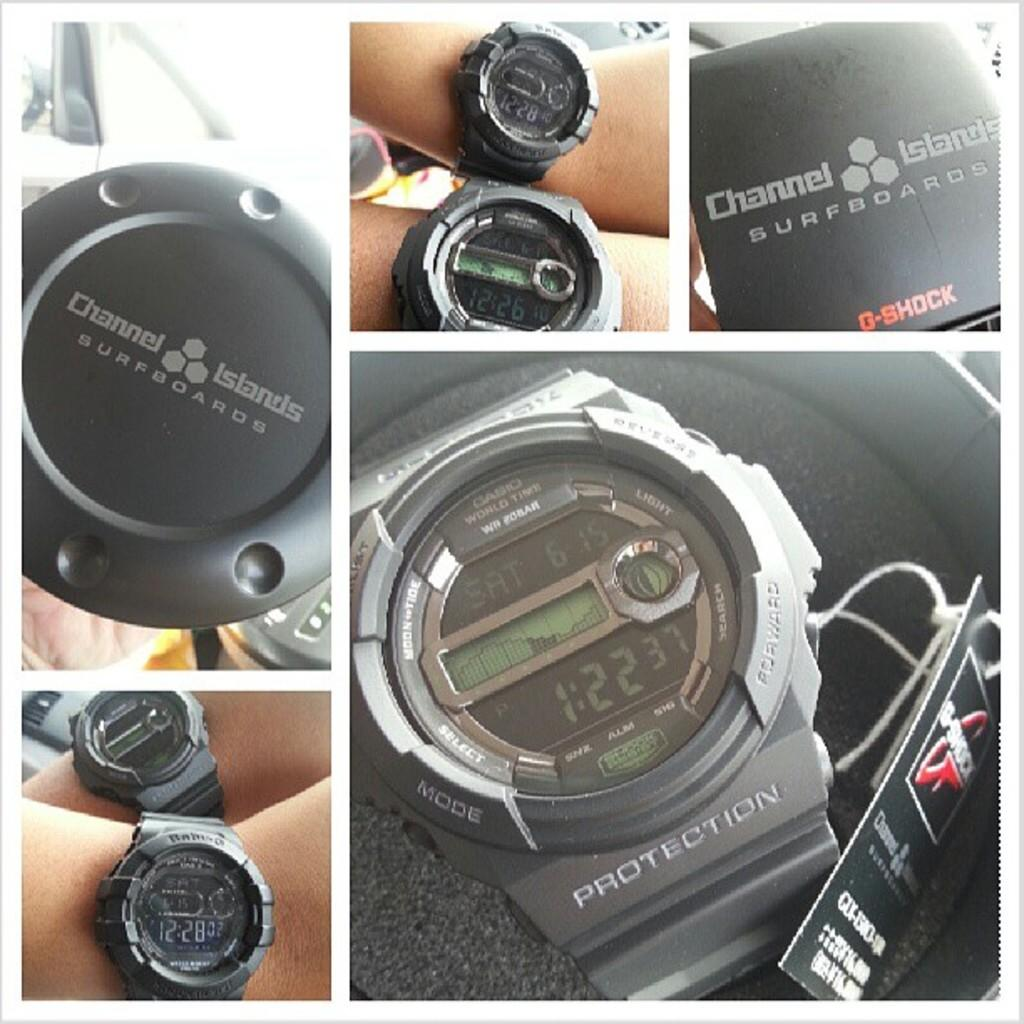<image>
Summarize the visual content of the image. many different shot of Channel Islands Surfboard G-shock wrist watch 